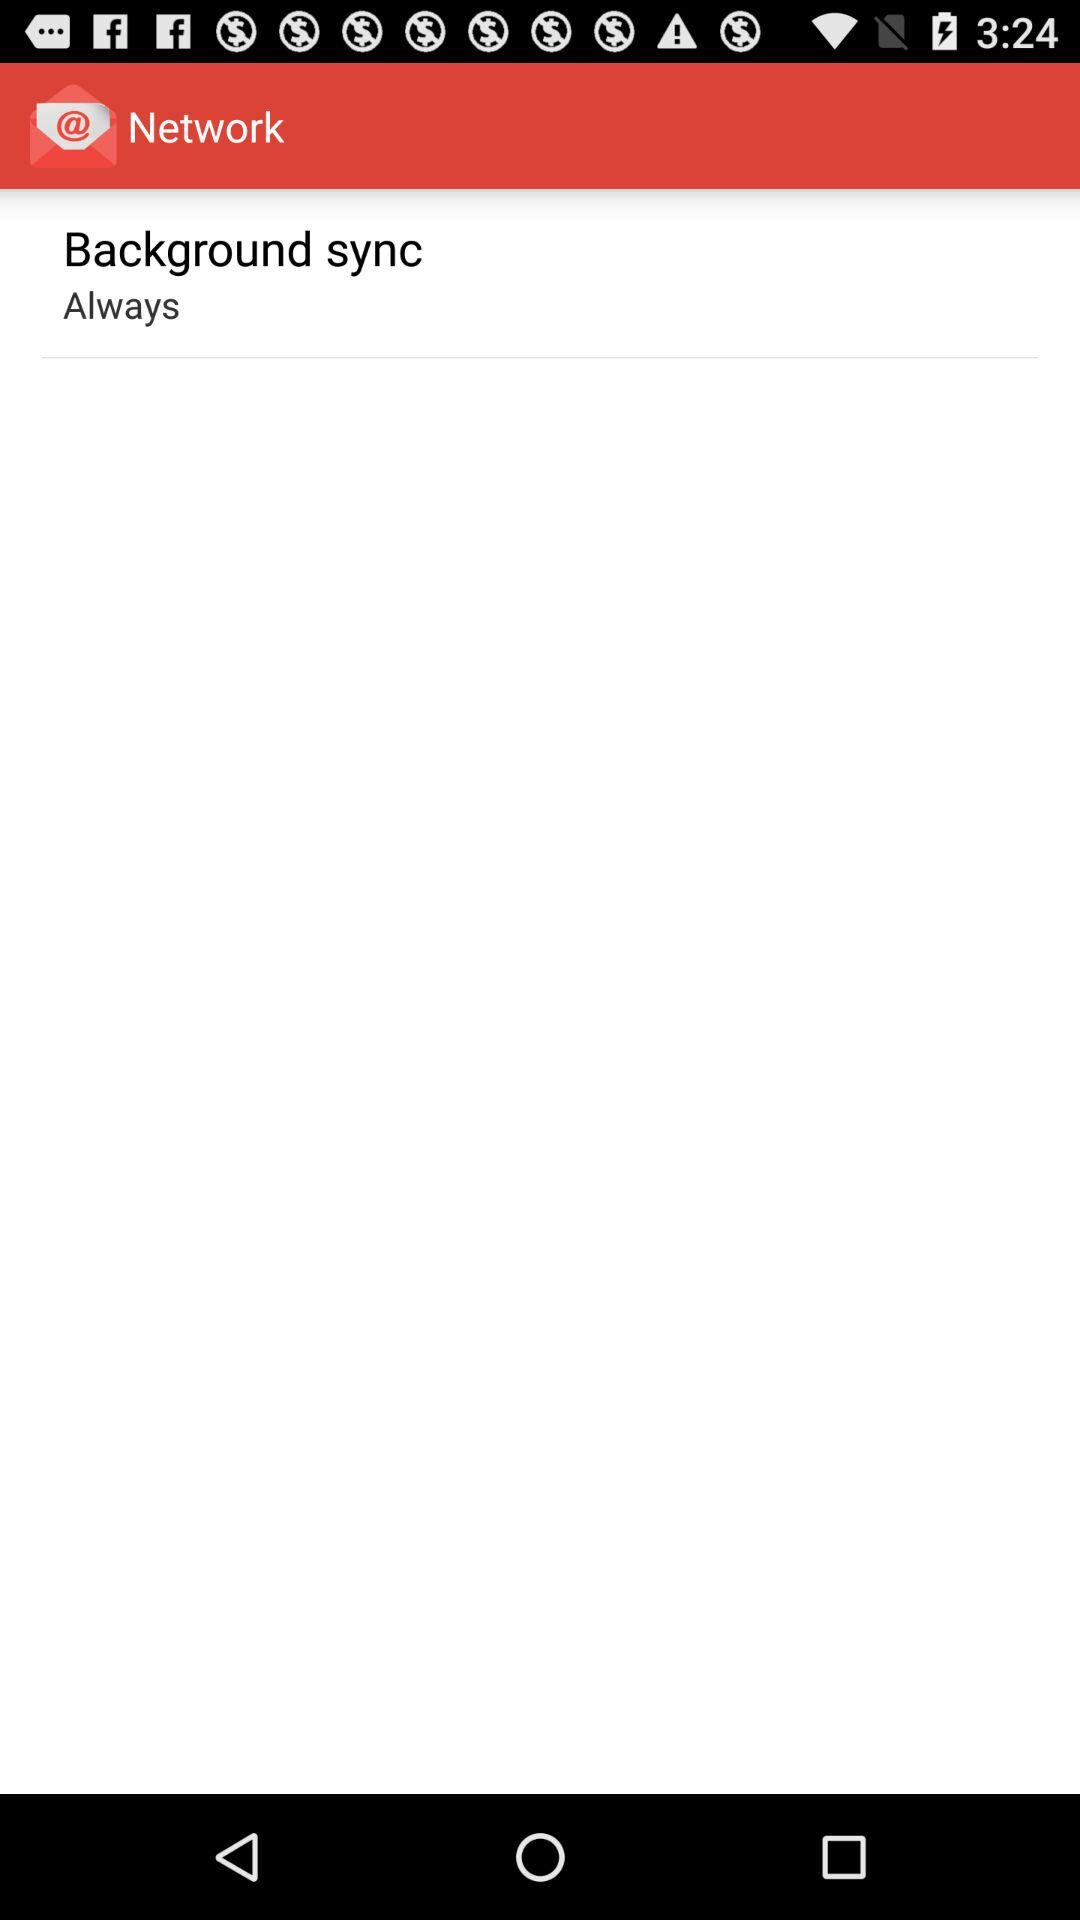What is the setting for background sync? The setting for background sync is "Always". 